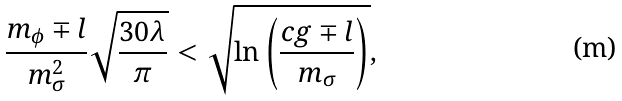Convert formula to latex. <formula><loc_0><loc_0><loc_500><loc_500>\frac { m _ { \phi } \mp l } { m _ { \sigma } ^ { 2 } } \sqrt { \frac { 3 0 \lambda } { \pi } } < \sqrt { \ln \left ( \frac { c g \mp l } { m _ { \sigma } } \right ) } ,</formula> 